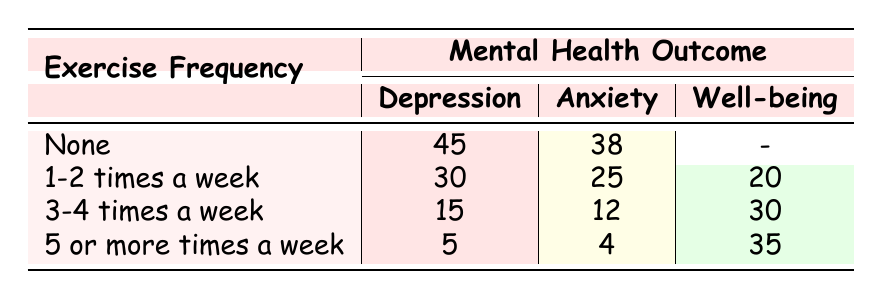What is the count of people who exercise 3-4 times a week and experience anxiety? From the table, we find the row for "3-4 times a week" under the "Anxiety" column, which shows a count of 12.
Answer: 12 What is the total number of people reporting depression across all exercise frequencies? To find this, we sum the counts of depression: 45 (None) + 30 (1-2 times a week) + 15 (3-4 times a week) + 5 (5 or more times a week) = 95.
Answer: 95 Is it true that more people report anxiety than well-being for those who exercise 1-2 times a week? Looking at the "1-2 times a week" row, the count for anxiety is 25, while for well-being it is 20. Since 25 is greater than 20, the statement is true.
Answer: Yes What percentage of people who exercise 5 or more times a week experience depression? For "5 or more times a week," the count for depression is 5, out of a total of 9 individuals (5 for depression and 4 for anxiety). To find the percentage: (5/9) * 100 ≈ 55.56%.
Answer: Approximately 55.56% How many more people report depression compared to anxiety for those who exercise 1-2 times a week? In the "1-2 times a week" row, 30 people report depression and 25 report anxiety. The difference is 30 - 25 = 5.
Answer: 5 What is the count of well-being for those who do not exercise at all? The row for "None" under well-being shows a dash (-), which indicates that no one reported well-being in that category.
Answer: 0 What is the highest count of mental health outcomes recorded for any exercise frequency? By checking each outcome, the highest count is 45 for depression among those who do not exercise at all.
Answer: 45 How does the count of well-being change as the exercise frequency increases from none to 5 or more times a week? The counts for well-being are: none (0), 1-2 times a week (20), 3-4 times a week (30), 5 or more times a week (35). This shows an increasing pattern.
Answer: Increasing pattern 